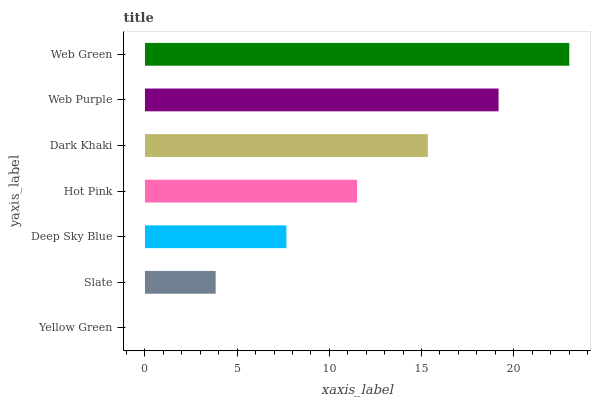Is Yellow Green the minimum?
Answer yes or no. Yes. Is Web Green the maximum?
Answer yes or no. Yes. Is Slate the minimum?
Answer yes or no. No. Is Slate the maximum?
Answer yes or no. No. Is Slate greater than Yellow Green?
Answer yes or no. Yes. Is Yellow Green less than Slate?
Answer yes or no. Yes. Is Yellow Green greater than Slate?
Answer yes or no. No. Is Slate less than Yellow Green?
Answer yes or no. No. Is Hot Pink the high median?
Answer yes or no. Yes. Is Hot Pink the low median?
Answer yes or no. Yes. Is Yellow Green the high median?
Answer yes or no. No. Is Yellow Green the low median?
Answer yes or no. No. 